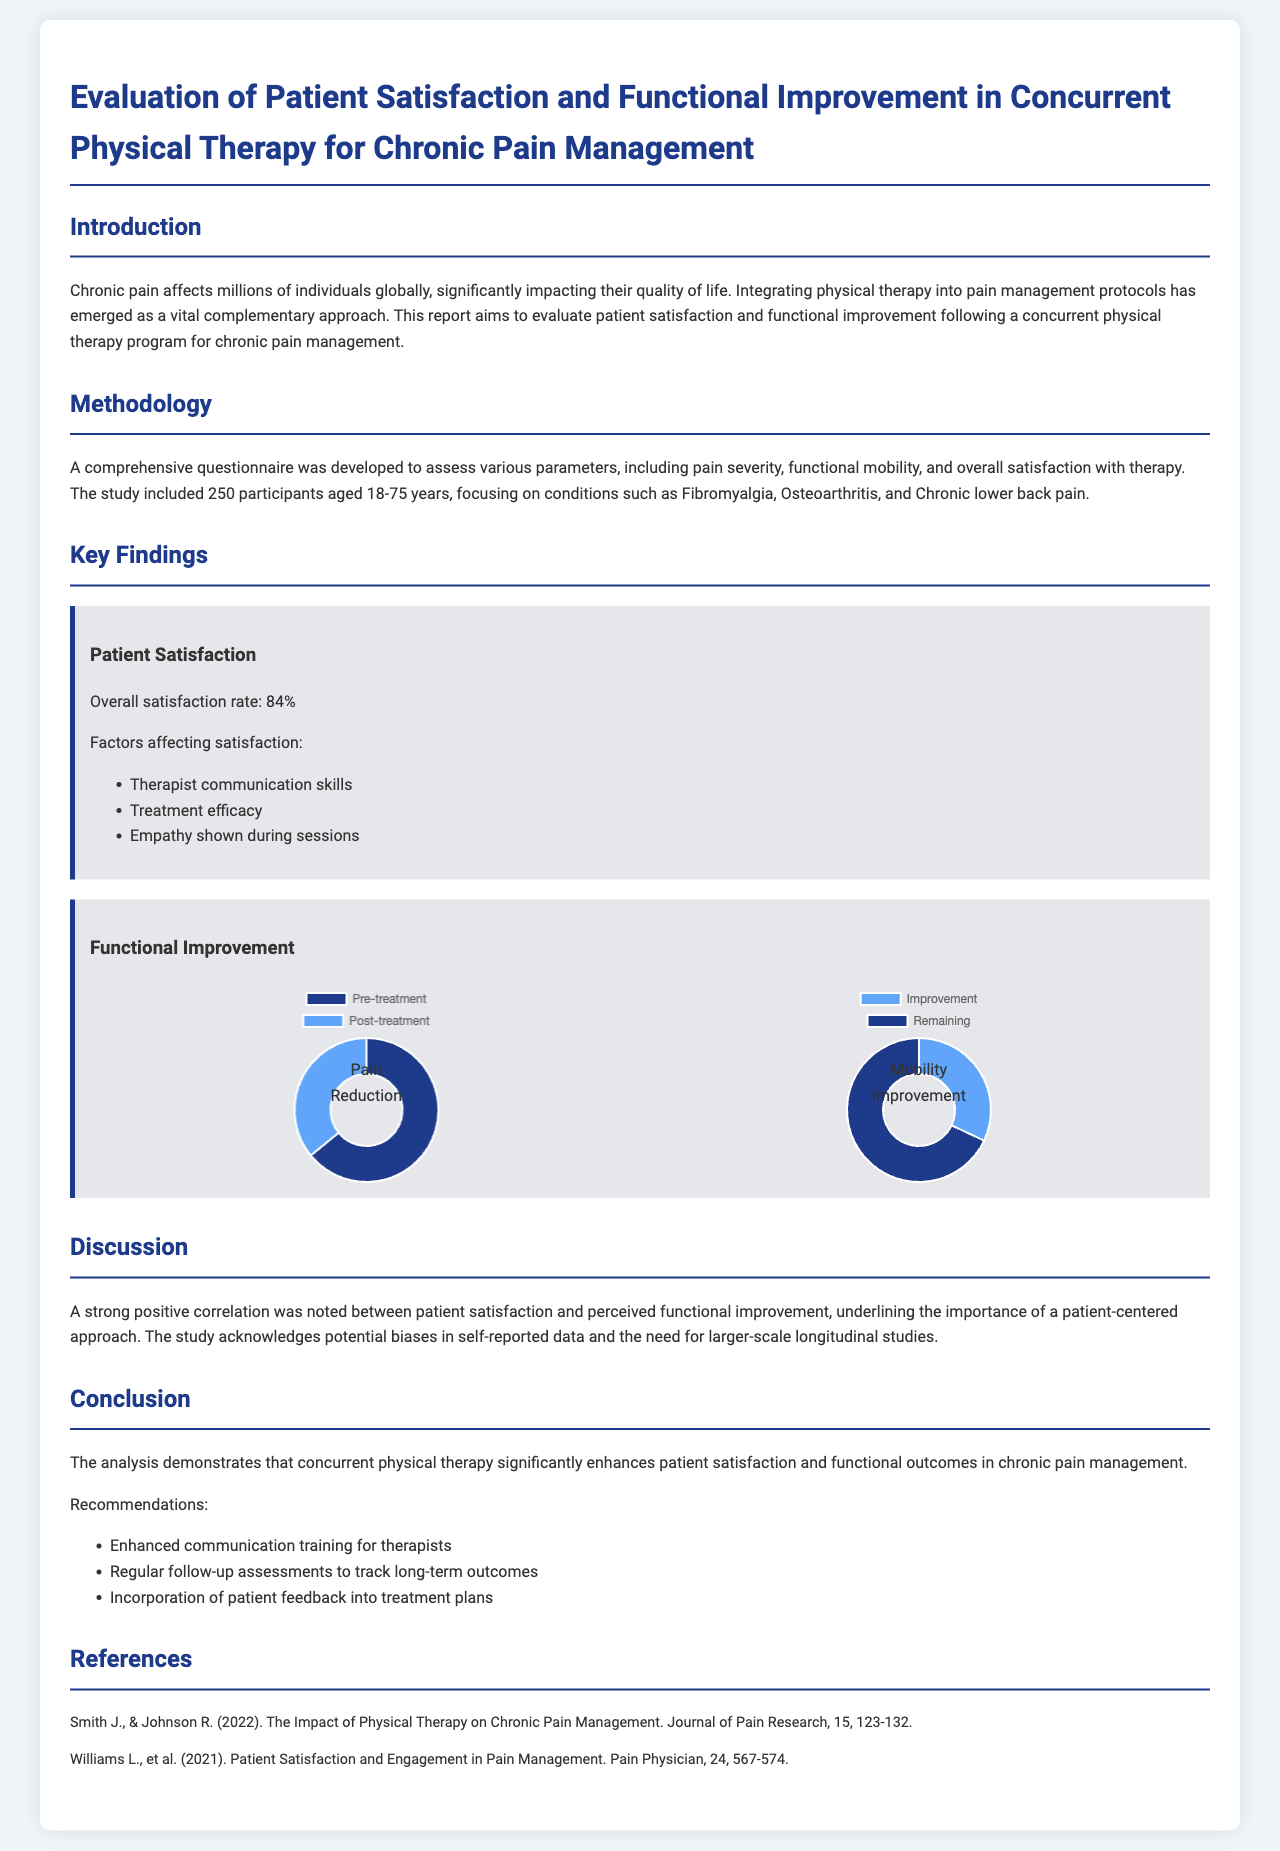What is the overall satisfaction rate? The overall satisfaction rate is the percentage of participants who reported satisfaction with the therapy, stated in the Key Findings section.
Answer: 84% What age range did the study participants fall into? The age range of the study participants is specified in the Methodology section.
Answer: 18-75 years Which conditions were focused on in the study? The conditions aimed for in the study are listed in the Methodology section of the report.
Answer: Fibromyalgia, Osteoarthritis, Chronic lower back pain What three factors were noted to affect patient satisfaction? The factors affecting satisfaction are outlined in the Key Findings section under Patient Satisfaction.
Answer: Therapist communication skills, Treatment efficacy, Empathy shown during sessions What is the average pain score pre-treatment? The average pain score pre-treatment is provided in the Pain Reduction Chart within the Key Findings section.
Answer: 7.5 What was the average time improvement in the Timed Up and Go Test? The average time improvement in seconds is mentioned in the Mobility Improvement Chart in the Key Findings section.
Answer: 3.2 What does a strong correlation between patient satisfaction and perceived functional improvement suggest? The positive correlation indicates a relationship noted in the Discussion section, emphasizing the importance of a patient-centered approach.
Answer: Importance of a patient-centered approach What is one of the recommendations made in the Conclusion? The recommendations made in the Conclusion section are suggestions based on the report's findings, focused on improving therapy outcomes.
Answer: Enhanced communication training for therapists What type of study design does the report acknowledge the need for? The report discusses the design that requires further exploration to validate the findings in the Discussion section.
Answer: Larger-scale longitudinal studies 